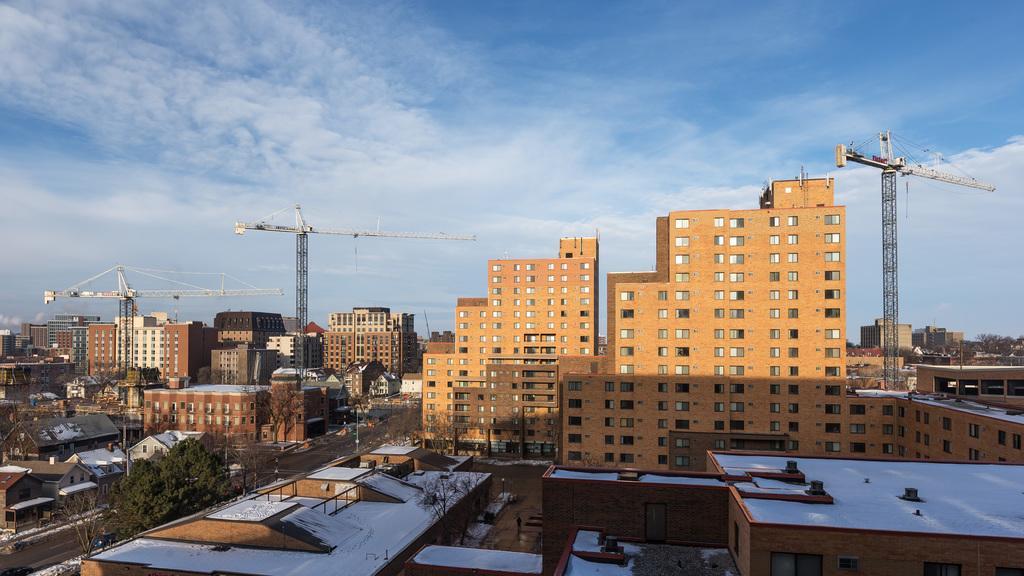How would you summarize this image in a sentence or two? This image is taken outdoors. At the top of the image there is a sky with clouds. In this image there are many buildings and houses with walls, windows, roofs, doors and balconies. There are three cranes. There are a few trees and poles. On the left side of the image there is a road. 